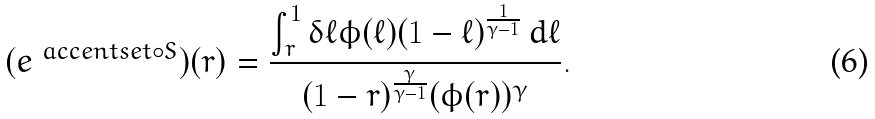Convert formula to latex. <formula><loc_0><loc_0><loc_500><loc_500>( e ^ { \ a c c e n t s e t { \circ } { S } } ) ( r ) = \frac { \int _ { r } ^ { 1 } \delta \ell \phi ( \ell ) ( 1 - \ell ) ^ { \frac { 1 } { \gamma - 1 } } \, d \ell } { ( 1 - r ) ^ { \frac { \gamma } { \gamma - 1 } } ( \phi ( r ) ) ^ { \gamma } } .</formula> 